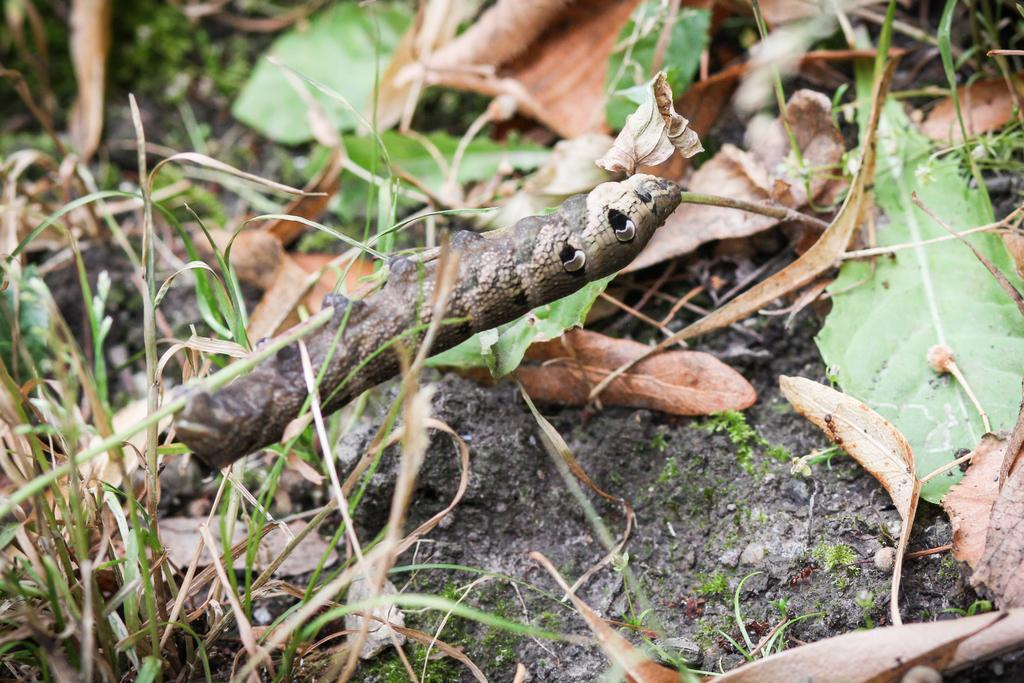What type of creature is in the image? There is a caterpillar in the image. What color is the caterpillar? The caterpillar is brown. What can be seen on the ground in the image? There are dried leaves on the ground in the image. What type of vegetation is visible in the image? There is grass visible in the image. What letter is the caterpillar holding in its hand in the image? There is no letter present in the image, and caterpillars do not have hands. 